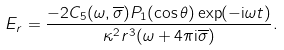Convert formula to latex. <formula><loc_0><loc_0><loc_500><loc_500>E _ { r } = \frac { - 2 C _ { 5 } ( \omega , \overline { \sigma } ) P _ { 1 } ( \cos \theta ) \exp ( - { \mathrm i } \omega t ) } { \kappa ^ { 2 } r ^ { 3 } ( \omega + 4 \pi { \mathrm i } \overline { \sigma } ) } .</formula> 